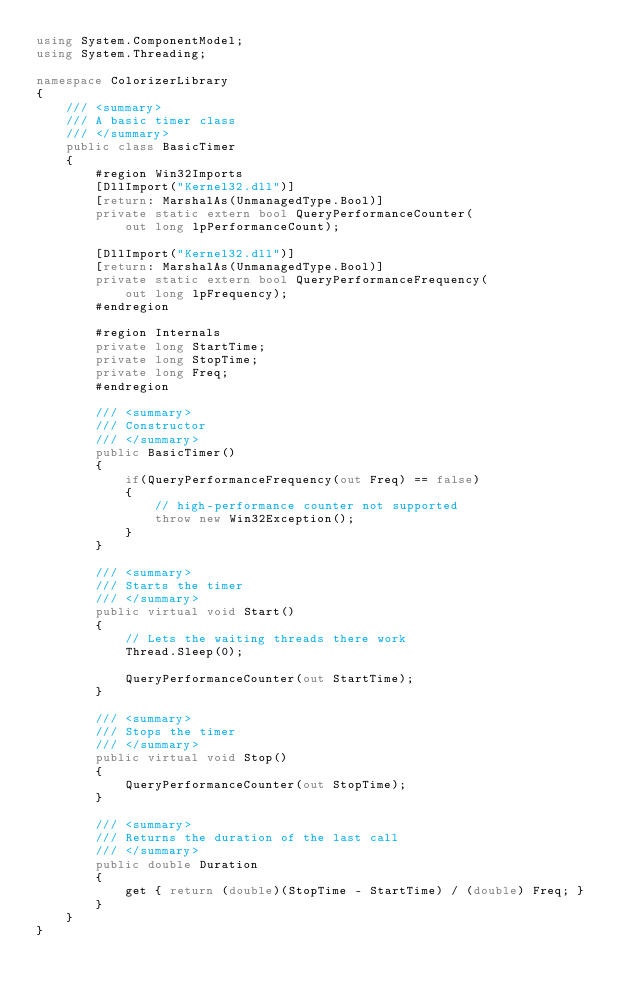<code> <loc_0><loc_0><loc_500><loc_500><_C#_>using System.ComponentModel;
using System.Threading;

namespace ColorizerLibrary
{
	/// <summary>
	/// A basic timer class
	/// </summary>
	public class BasicTimer
	{
        #region Win32Imports
		[DllImport("Kernel32.dll")]
        [return: MarshalAs(UnmanagedType.Bool)]
		private static extern bool QueryPerformanceCounter(
            out long lpPerformanceCount);  

		[DllImport("Kernel32.dll")]
        [return: MarshalAs(UnmanagedType.Bool)]
        private static extern bool QueryPerformanceFrequency(
            out long lpFrequency);
		#endregion
		
		#region Internals
		private long StartTime;
		private long StopTime;
		private long Freq;
		#endregion
		
		/// <summary>
		/// Constructor
		/// </summary>
		public BasicTimer()
		{
			if(QueryPerformanceFrequency(out Freq) == false)
			{
				// high-performance counter not supported 
				throw new Win32Exception(); 
			}
		}
		
		/// <summary>
		/// Starts the timer
		/// </summary>
		public virtual void Start()
		{
			// Lets the waiting threads there work
			Thread.Sleep(0);  

			QueryPerformanceCounter(out StartTime);
		}
		
		/// <summary>
		/// Stops the timer
		/// </summary>
		public virtual void Stop()
		{
			QueryPerformanceCounter(out StopTime);
		}
		
		/// <summary>
		/// Returns the duration of the last call
		/// </summary>
		public double Duration
		{
			get { return (double)(StopTime - StartTime) / (double) Freq; }
		}
	}
}
</code> 